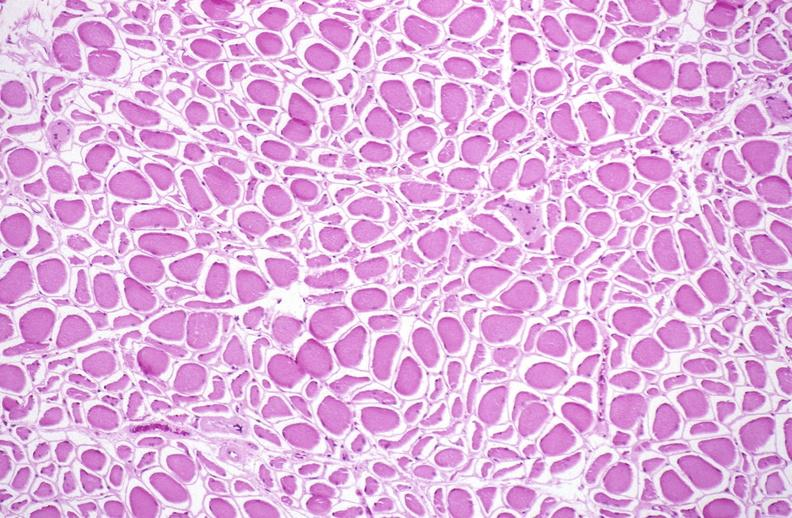what does this image show?
Answer the question using a single word or phrase. Skeletal muscle atrophy 